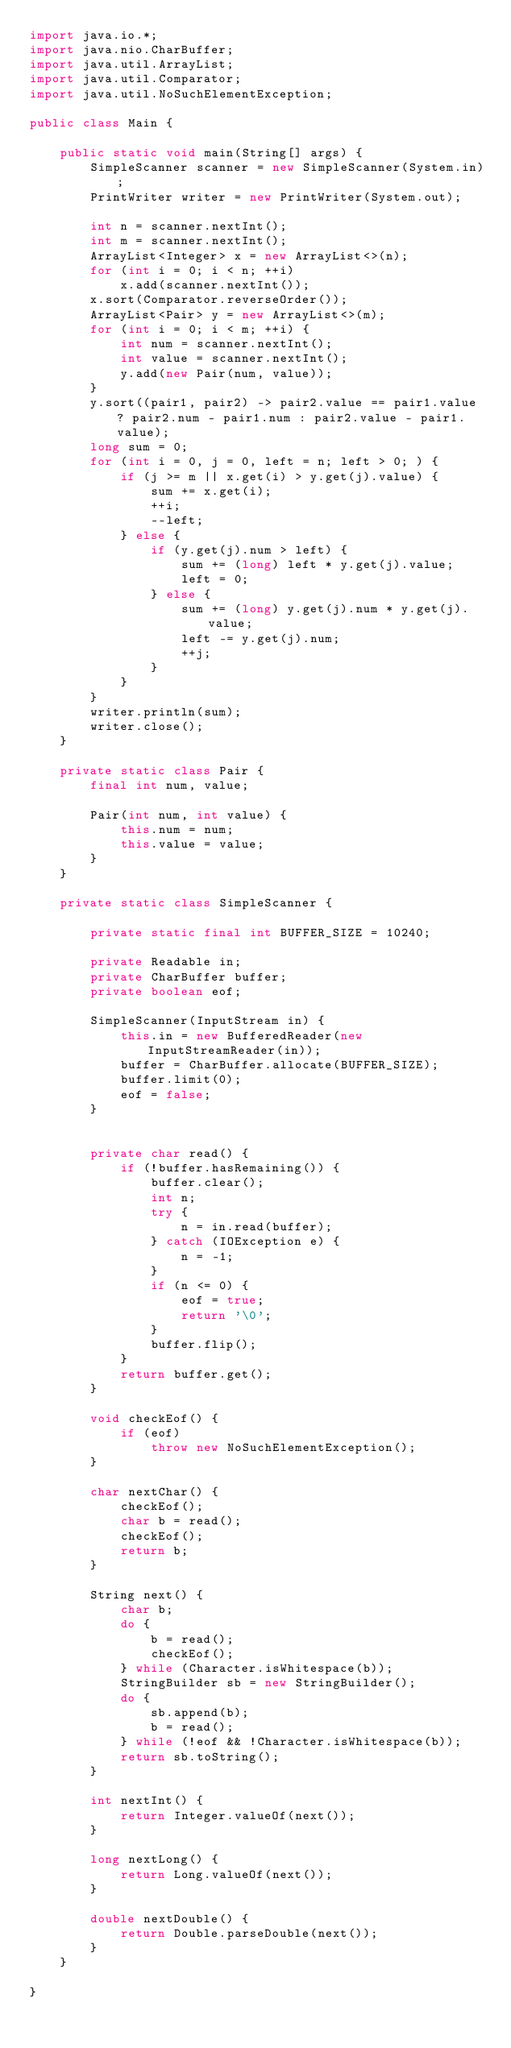Convert code to text. <code><loc_0><loc_0><loc_500><loc_500><_Java_>import java.io.*;
import java.nio.CharBuffer;
import java.util.ArrayList;
import java.util.Comparator;
import java.util.NoSuchElementException;

public class Main {

    public static void main(String[] args) {
        SimpleScanner scanner = new SimpleScanner(System.in);
        PrintWriter writer = new PrintWriter(System.out);

        int n = scanner.nextInt();
        int m = scanner.nextInt();
        ArrayList<Integer> x = new ArrayList<>(n);
        for (int i = 0; i < n; ++i)
            x.add(scanner.nextInt());
        x.sort(Comparator.reverseOrder());
        ArrayList<Pair> y = new ArrayList<>(m);
        for (int i = 0; i < m; ++i) {
            int num = scanner.nextInt();
            int value = scanner.nextInt();
            y.add(new Pair(num, value));
        }
        y.sort((pair1, pair2) -> pair2.value == pair1.value ? pair2.num - pair1.num : pair2.value - pair1.value);
        long sum = 0;
        for (int i = 0, j = 0, left = n; left > 0; ) {
            if (j >= m || x.get(i) > y.get(j).value) {
                sum += x.get(i);
                ++i;
                --left;
            } else {
                if (y.get(j).num > left) {
                    sum += (long) left * y.get(j).value;
                    left = 0;
                } else {
                    sum += (long) y.get(j).num * y.get(j).value;
                    left -= y.get(j).num;
                    ++j;
                }
            }
        }
        writer.println(sum);
        writer.close();
    }

    private static class Pair {
        final int num, value;

        Pair(int num, int value) {
            this.num = num;
            this.value = value;
        }
    }

    private static class SimpleScanner {

        private static final int BUFFER_SIZE = 10240;

        private Readable in;
        private CharBuffer buffer;
        private boolean eof;

        SimpleScanner(InputStream in) {
            this.in = new BufferedReader(new InputStreamReader(in));
            buffer = CharBuffer.allocate(BUFFER_SIZE);
            buffer.limit(0);
            eof = false;
        }


        private char read() {
            if (!buffer.hasRemaining()) {
                buffer.clear();
                int n;
                try {
                    n = in.read(buffer);
                } catch (IOException e) {
                    n = -1;
                }
                if (n <= 0) {
                    eof = true;
                    return '\0';
                }
                buffer.flip();
            }
            return buffer.get();
        }

        void checkEof() {
            if (eof)
                throw new NoSuchElementException();
        }

        char nextChar() {
            checkEof();
            char b = read();
            checkEof();
            return b;
        }

        String next() {
            char b;
            do {
                b = read();
                checkEof();
            } while (Character.isWhitespace(b));
            StringBuilder sb = new StringBuilder();
            do {
                sb.append(b);
                b = read();
            } while (!eof && !Character.isWhitespace(b));
            return sb.toString();
        }

        int nextInt() {
            return Integer.valueOf(next());
        }

        long nextLong() {
            return Long.valueOf(next());
        }

        double nextDouble() {
            return Double.parseDouble(next());
        }
    }

}</code> 